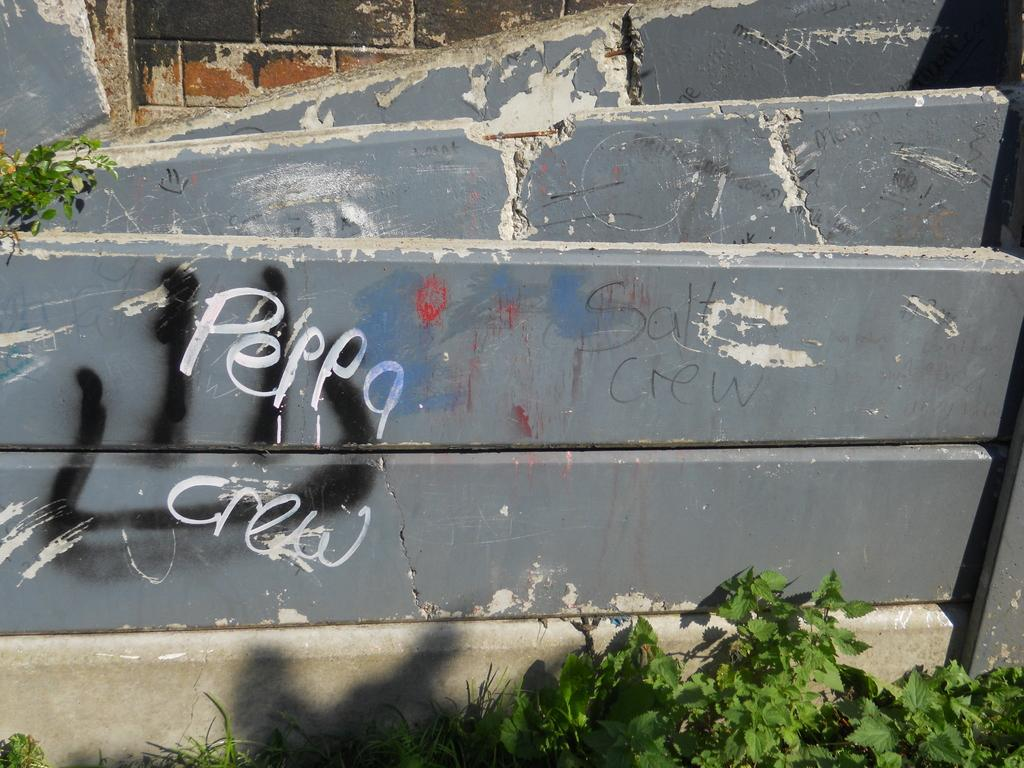What is written or displayed on the wall in the image? There is text on the wall in the image. What type of vegetation can be seen in the image? There are plants and grass visible in the image. What type of bird can be seen sitting on the flower in the image? There is no bird or flower present in the image. What type of thrill can be felt by the person in the image? There is no person in the image, so it's not possible to determine what type of thrill they might be feeling. 